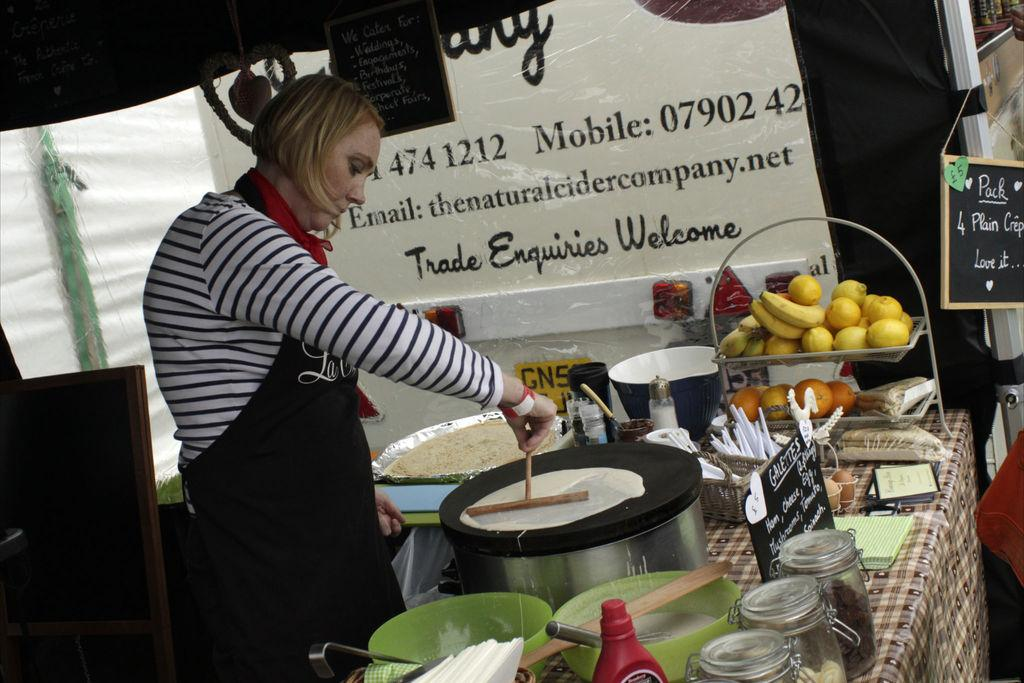What is the person holding in the image? The person is holding a stick in the image. What type of furniture is present in the image? There is a table in the image. What type of containers are visible in the image? There are bowls and jars in the image. What type of storage item is present in the image? There is a basket in the image. What type of disposable item is present in the image? There are tissue papers in the image. What type of signage is present in the image? There are name boards in the image. What type of food items are visible in the image? There are fruits in the image. What type of decorative item is present in the image? There is a banner in the image. What other unspecified objects are present in the image? There are some unspecified objects in the image. What type of throat soothing remedy is present in the image? There is no throat soothing remedy present in the image. What type of maid is visible in the image? There is no maid present in the image. 